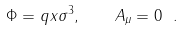Convert formula to latex. <formula><loc_0><loc_0><loc_500><loc_500>\Phi = q x \sigma ^ { 3 } , \quad A _ { \mu } = 0 \ .</formula> 